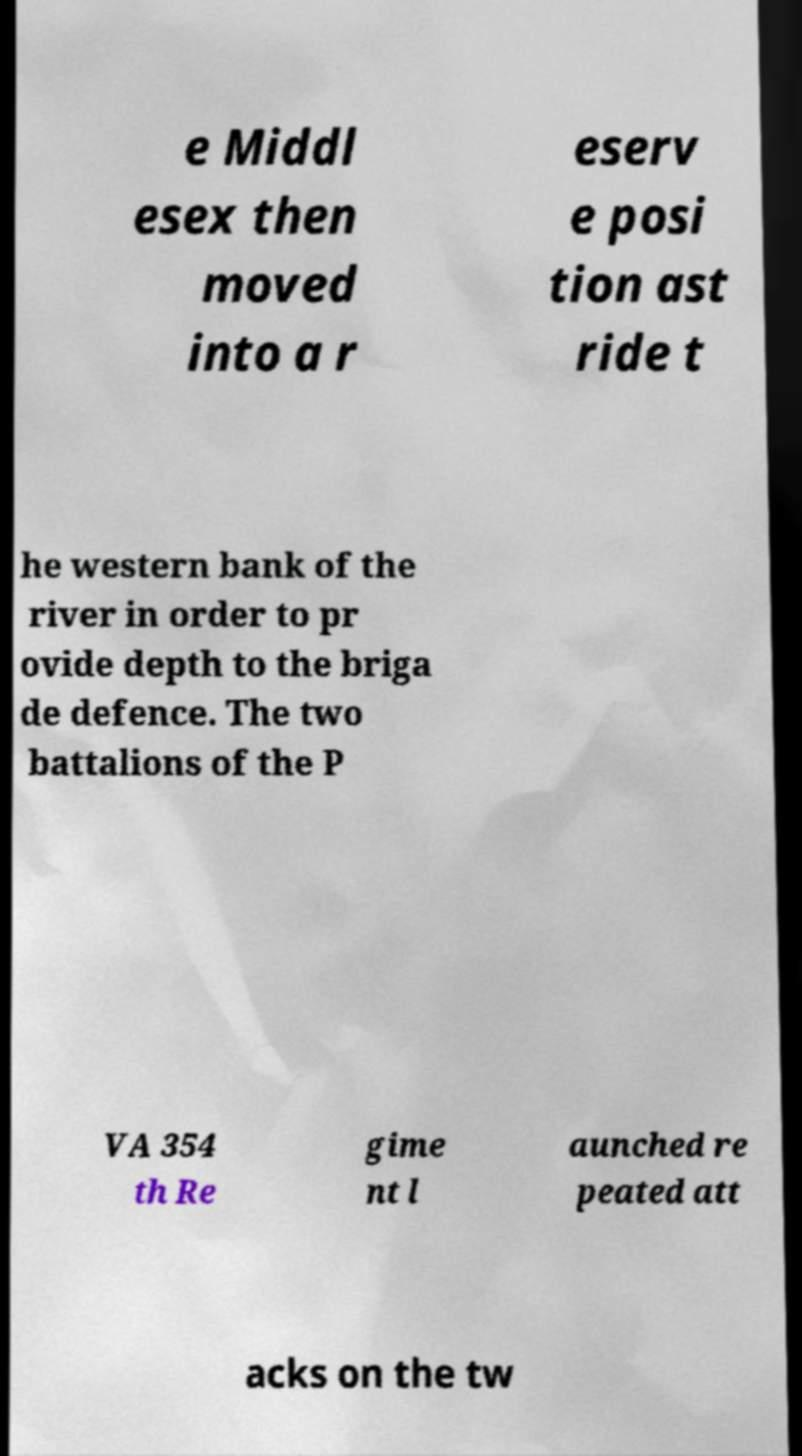What messages or text are displayed in this image? I need them in a readable, typed format. e Middl esex then moved into a r eserv e posi tion ast ride t he western bank of the river in order to pr ovide depth to the briga de defence. The two battalions of the P VA 354 th Re gime nt l aunched re peated att acks on the tw 